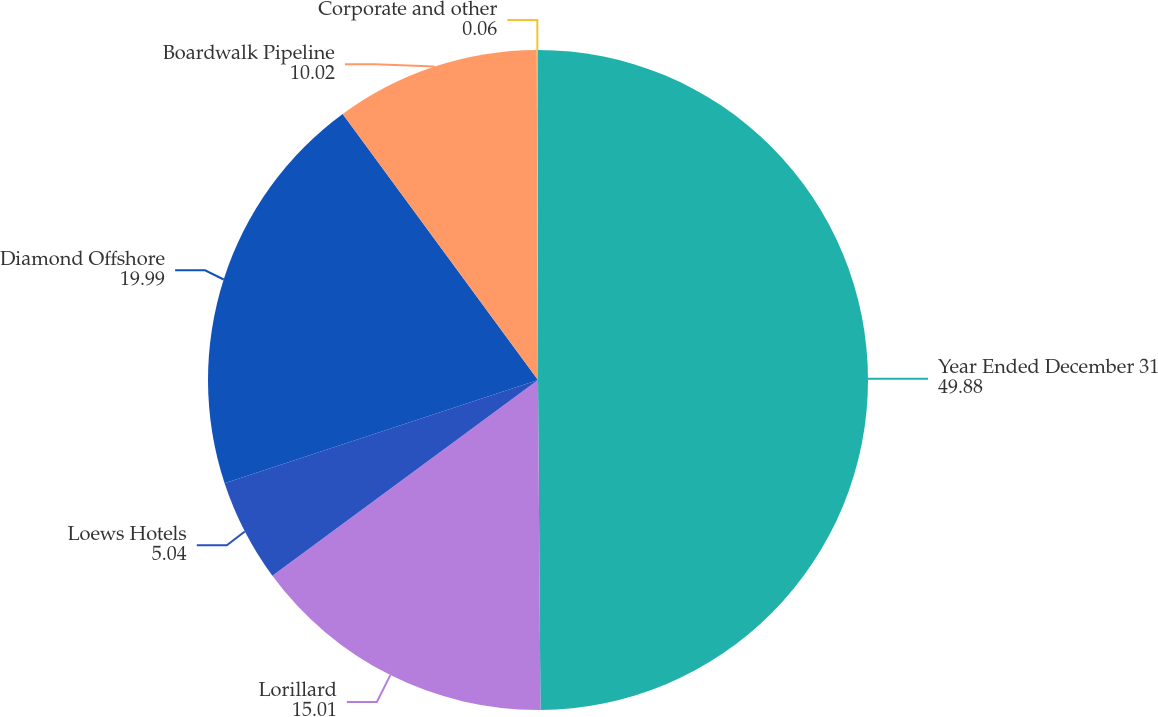Convert chart to OTSL. <chart><loc_0><loc_0><loc_500><loc_500><pie_chart><fcel>Year Ended December 31<fcel>Lorillard<fcel>Loews Hotels<fcel>Diamond Offshore<fcel>Boardwalk Pipeline<fcel>Corporate and other<nl><fcel>49.88%<fcel>15.01%<fcel>5.04%<fcel>19.99%<fcel>10.02%<fcel>0.06%<nl></chart> 